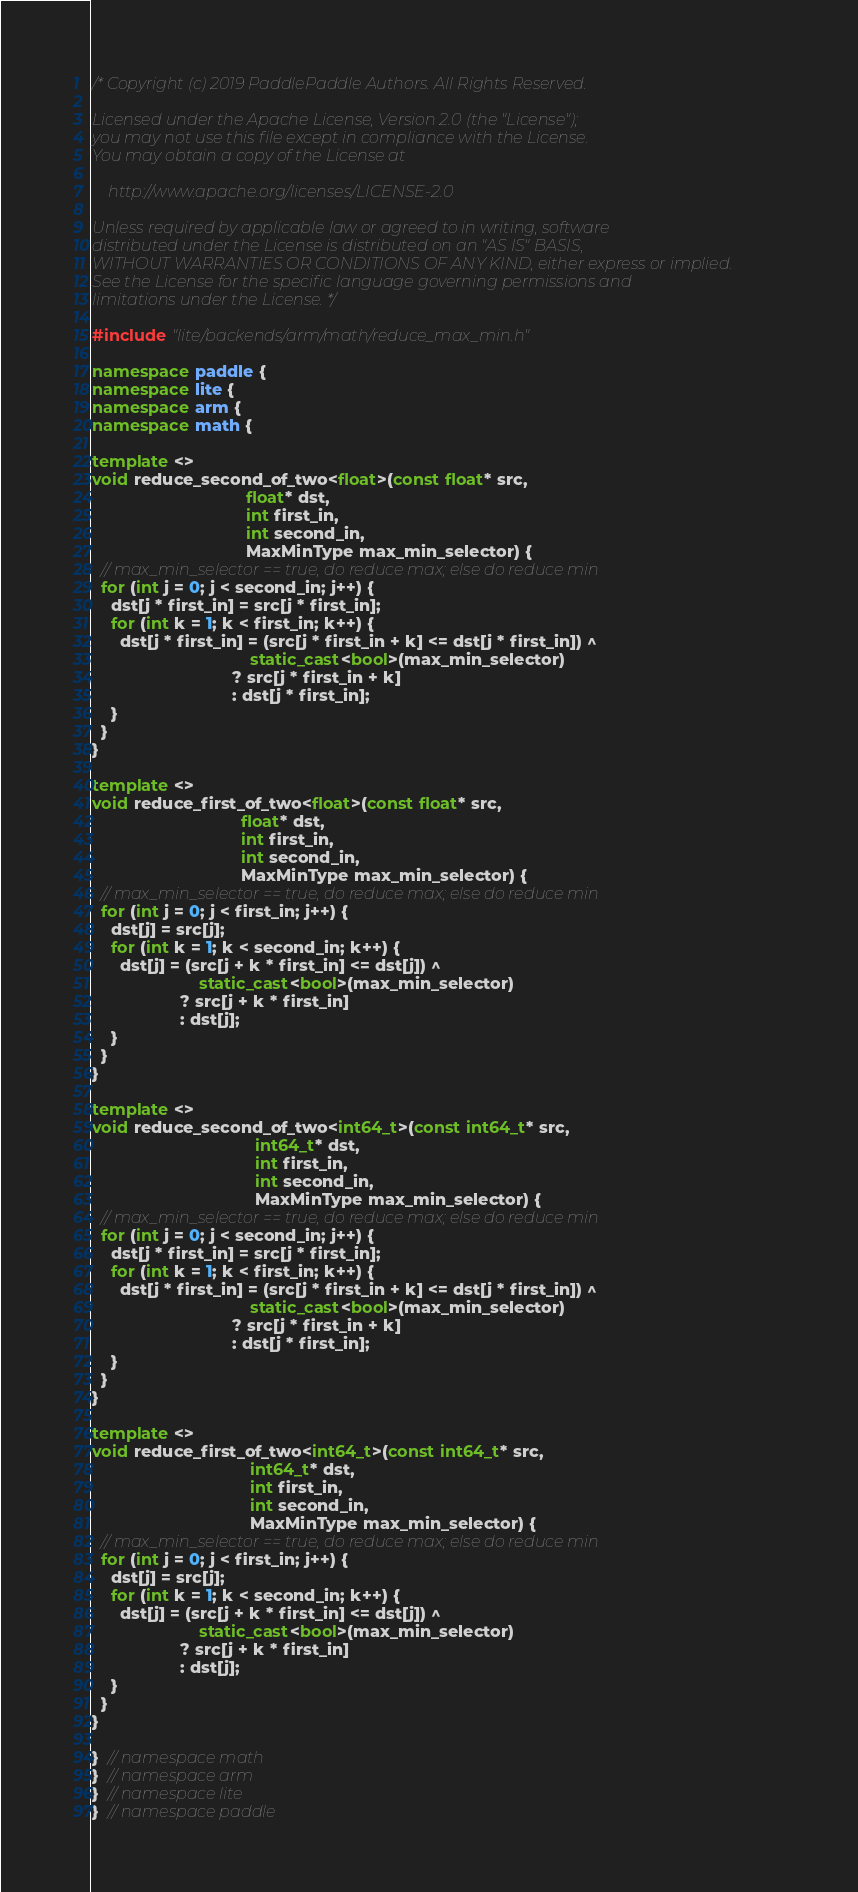<code> <loc_0><loc_0><loc_500><loc_500><_C++_>/* Copyright (c) 2019 PaddlePaddle Authors. All Rights Reserved.

Licensed under the Apache License, Version 2.0 (the "License");
you may not use this file except in compliance with the License.
You may obtain a copy of the License at

    http://www.apache.org/licenses/LICENSE-2.0

Unless required by applicable law or agreed to in writing, software
distributed under the License is distributed on an "AS IS" BASIS,
WITHOUT WARRANTIES OR CONDITIONS OF ANY KIND, either express or implied.
See the License for the specific language governing permissions and
limitations under the License. */

#include "lite/backends/arm/math/reduce_max_min.h"

namespace paddle {
namespace lite {
namespace arm {
namespace math {

template <>
void reduce_second_of_two<float>(const float* src,
                                 float* dst,
                                 int first_in,
                                 int second_in,
                                 MaxMinType max_min_selector) {
  // max_min_selector == true, do reduce max; else do reduce min
  for (int j = 0; j < second_in; j++) {
    dst[j * first_in] = src[j * first_in];
    for (int k = 1; k < first_in; k++) {
      dst[j * first_in] = (src[j * first_in + k] <= dst[j * first_in]) ^
                                  static_cast<bool>(max_min_selector)
                              ? src[j * first_in + k]
                              : dst[j * first_in];
    }
  }
}

template <>
void reduce_first_of_two<float>(const float* src,
                                float* dst,
                                int first_in,
                                int second_in,
                                MaxMinType max_min_selector) {
  // max_min_selector == true, do reduce max; else do reduce min
  for (int j = 0; j < first_in; j++) {
    dst[j] = src[j];
    for (int k = 1; k < second_in; k++) {
      dst[j] = (src[j + k * first_in] <= dst[j]) ^
                       static_cast<bool>(max_min_selector)
                   ? src[j + k * first_in]
                   : dst[j];
    }
  }
}

template <>
void reduce_second_of_two<int64_t>(const int64_t* src,
                                   int64_t* dst,
                                   int first_in,
                                   int second_in,
                                   MaxMinType max_min_selector) {
  // max_min_selector == true, do reduce max; else do reduce min
  for (int j = 0; j < second_in; j++) {
    dst[j * first_in] = src[j * first_in];
    for (int k = 1; k < first_in; k++) {
      dst[j * first_in] = (src[j * first_in + k] <= dst[j * first_in]) ^
                                  static_cast<bool>(max_min_selector)
                              ? src[j * first_in + k]
                              : dst[j * first_in];
    }
  }
}

template <>
void reduce_first_of_two<int64_t>(const int64_t* src,
                                  int64_t* dst,
                                  int first_in,
                                  int second_in,
                                  MaxMinType max_min_selector) {
  // max_min_selector == true, do reduce max; else do reduce min
  for (int j = 0; j < first_in; j++) {
    dst[j] = src[j];
    for (int k = 1; k < second_in; k++) {
      dst[j] = (src[j + k * first_in] <= dst[j]) ^
                       static_cast<bool>(max_min_selector)
                   ? src[j + k * first_in]
                   : dst[j];
    }
  }
}

}  // namespace math
}  // namespace arm
}  // namespace lite
}  // namespace paddle
</code> 